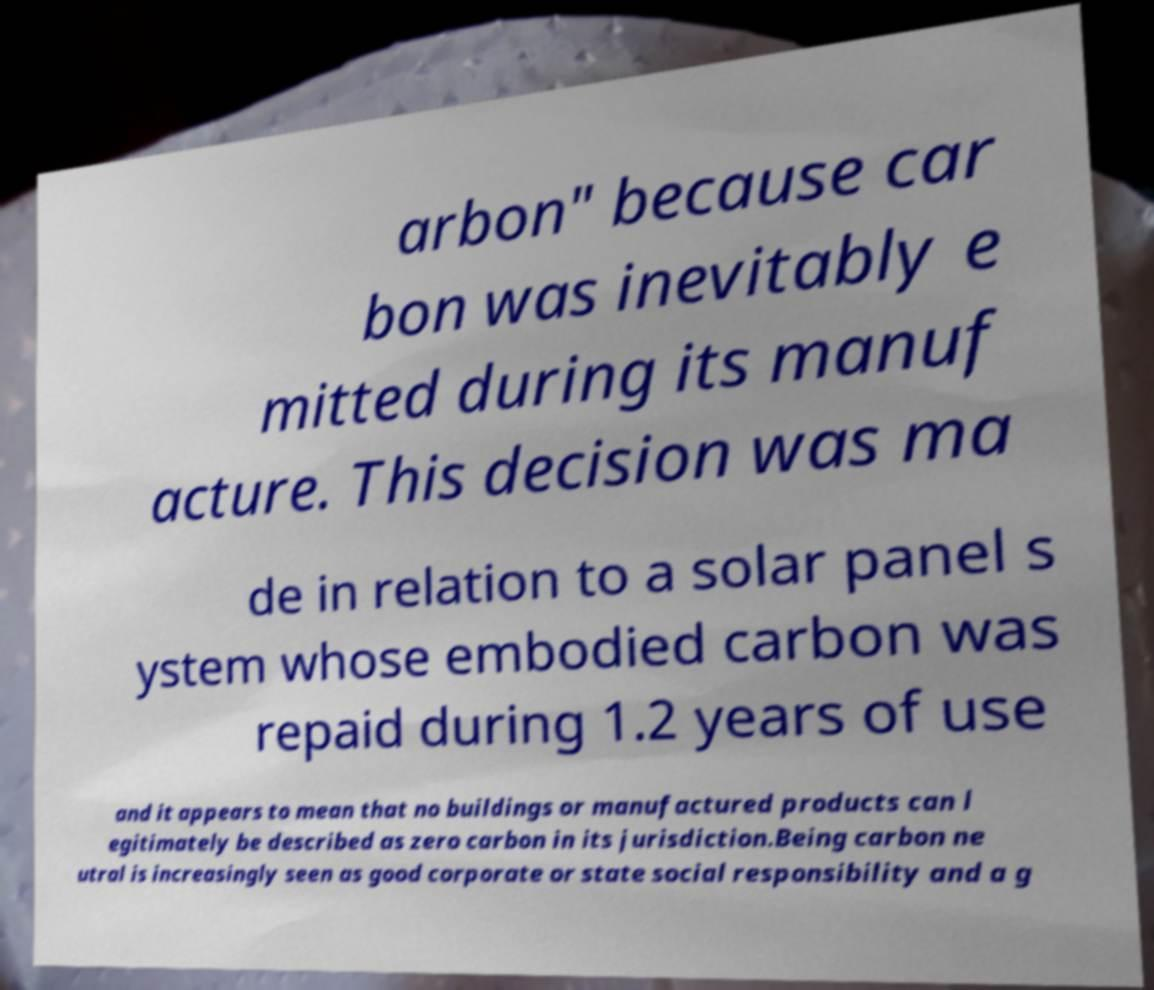Can you read and provide the text displayed in the image?This photo seems to have some interesting text. Can you extract and type it out for me? arbon" because car bon was inevitably e mitted during its manuf acture. This decision was ma de in relation to a solar panel s ystem whose embodied carbon was repaid during 1.2 years of use and it appears to mean that no buildings or manufactured products can l egitimately be described as zero carbon in its jurisdiction.Being carbon ne utral is increasingly seen as good corporate or state social responsibility and a g 